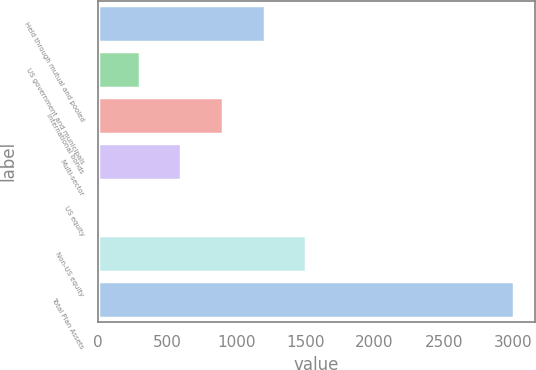Convert chart. <chart><loc_0><loc_0><loc_500><loc_500><bar_chart><fcel>Held through mutual and pooled<fcel>US government and municipals<fcel>International bonds<fcel>Multi-sector<fcel>US equity<fcel>Non-US equity<fcel>Total Plan Assets<nl><fcel>1205.4<fcel>302.1<fcel>904.3<fcel>603.2<fcel>1<fcel>1506.5<fcel>3012<nl></chart> 